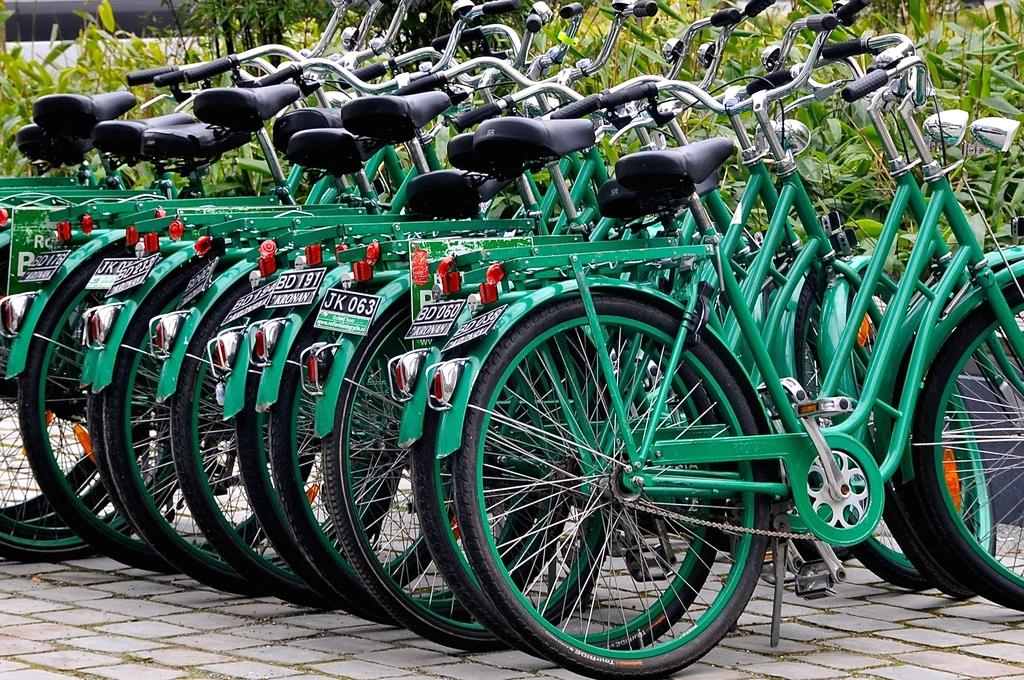What objects are on the floor in the image? There are bicycles on the floor in the image. What type of vegetation can be seen in the background of the image? There are plants with leaves in the background of the image. What type of print can be seen on the bicycles in the image? There is no specific print mentioned on the bicycles in the image; they are not described in detail. 